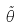Convert formula to latex. <formula><loc_0><loc_0><loc_500><loc_500>\tilde { \theta }</formula> 